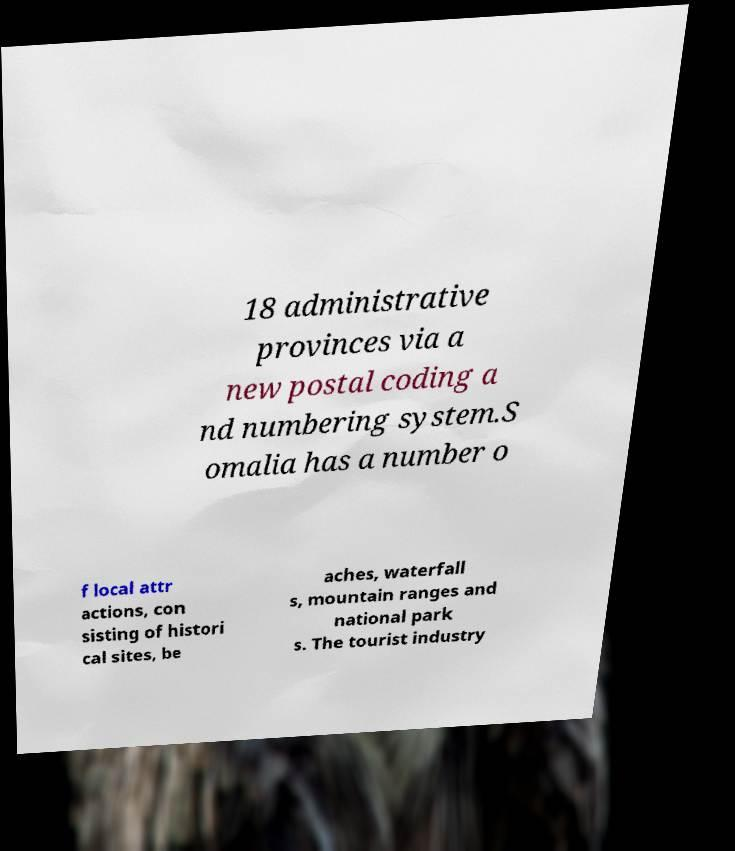Please identify and transcribe the text found in this image. 18 administrative provinces via a new postal coding a nd numbering system.S omalia has a number o f local attr actions, con sisting of histori cal sites, be aches, waterfall s, mountain ranges and national park s. The tourist industry 